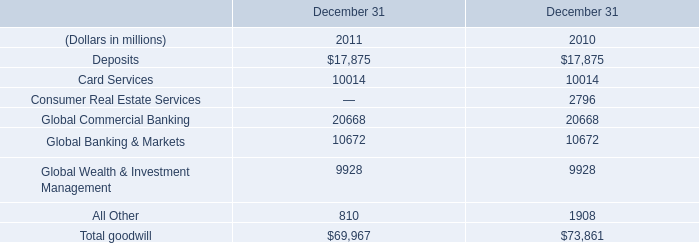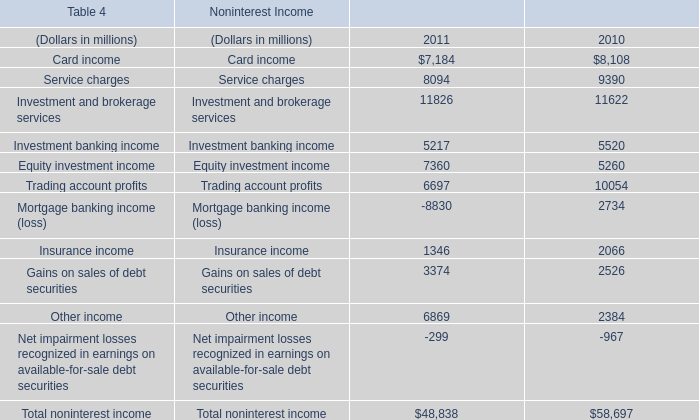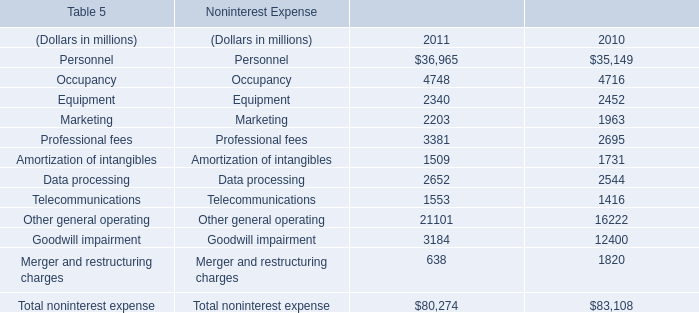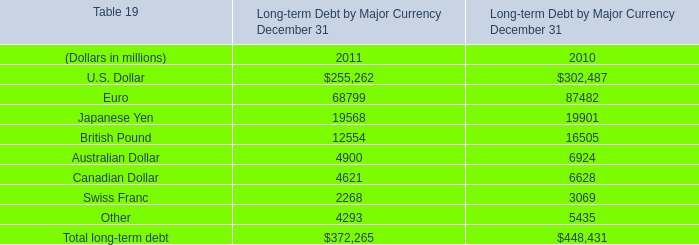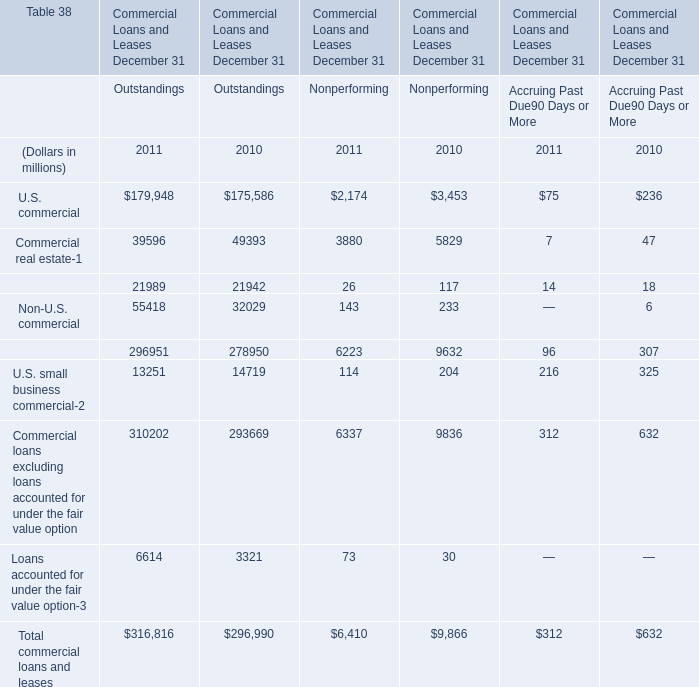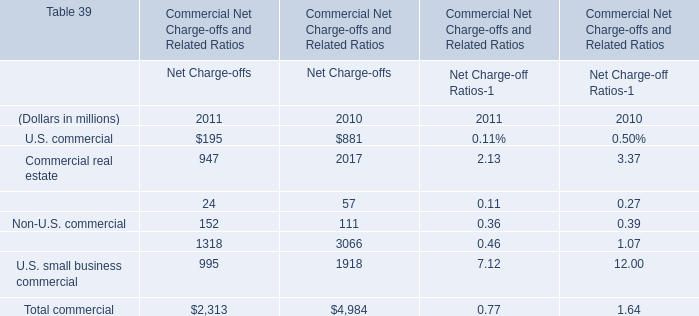What's the total amount of U.S. commercial, Commercial real estate,Commercial lease financing and Non-U.S. commercial in terms of Net Charge-offs in 2011? (in dollars in millions) 
Answer: 1318. 